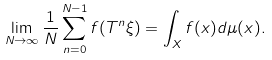<formula> <loc_0><loc_0><loc_500><loc_500>\lim _ { N \rightarrow \infty } \frac { 1 } { N } \sum ^ { N - 1 } _ { n = 0 } f ( T ^ { n } \xi ) = \int _ { X } f ( x ) d \mu ( x ) .</formula> 